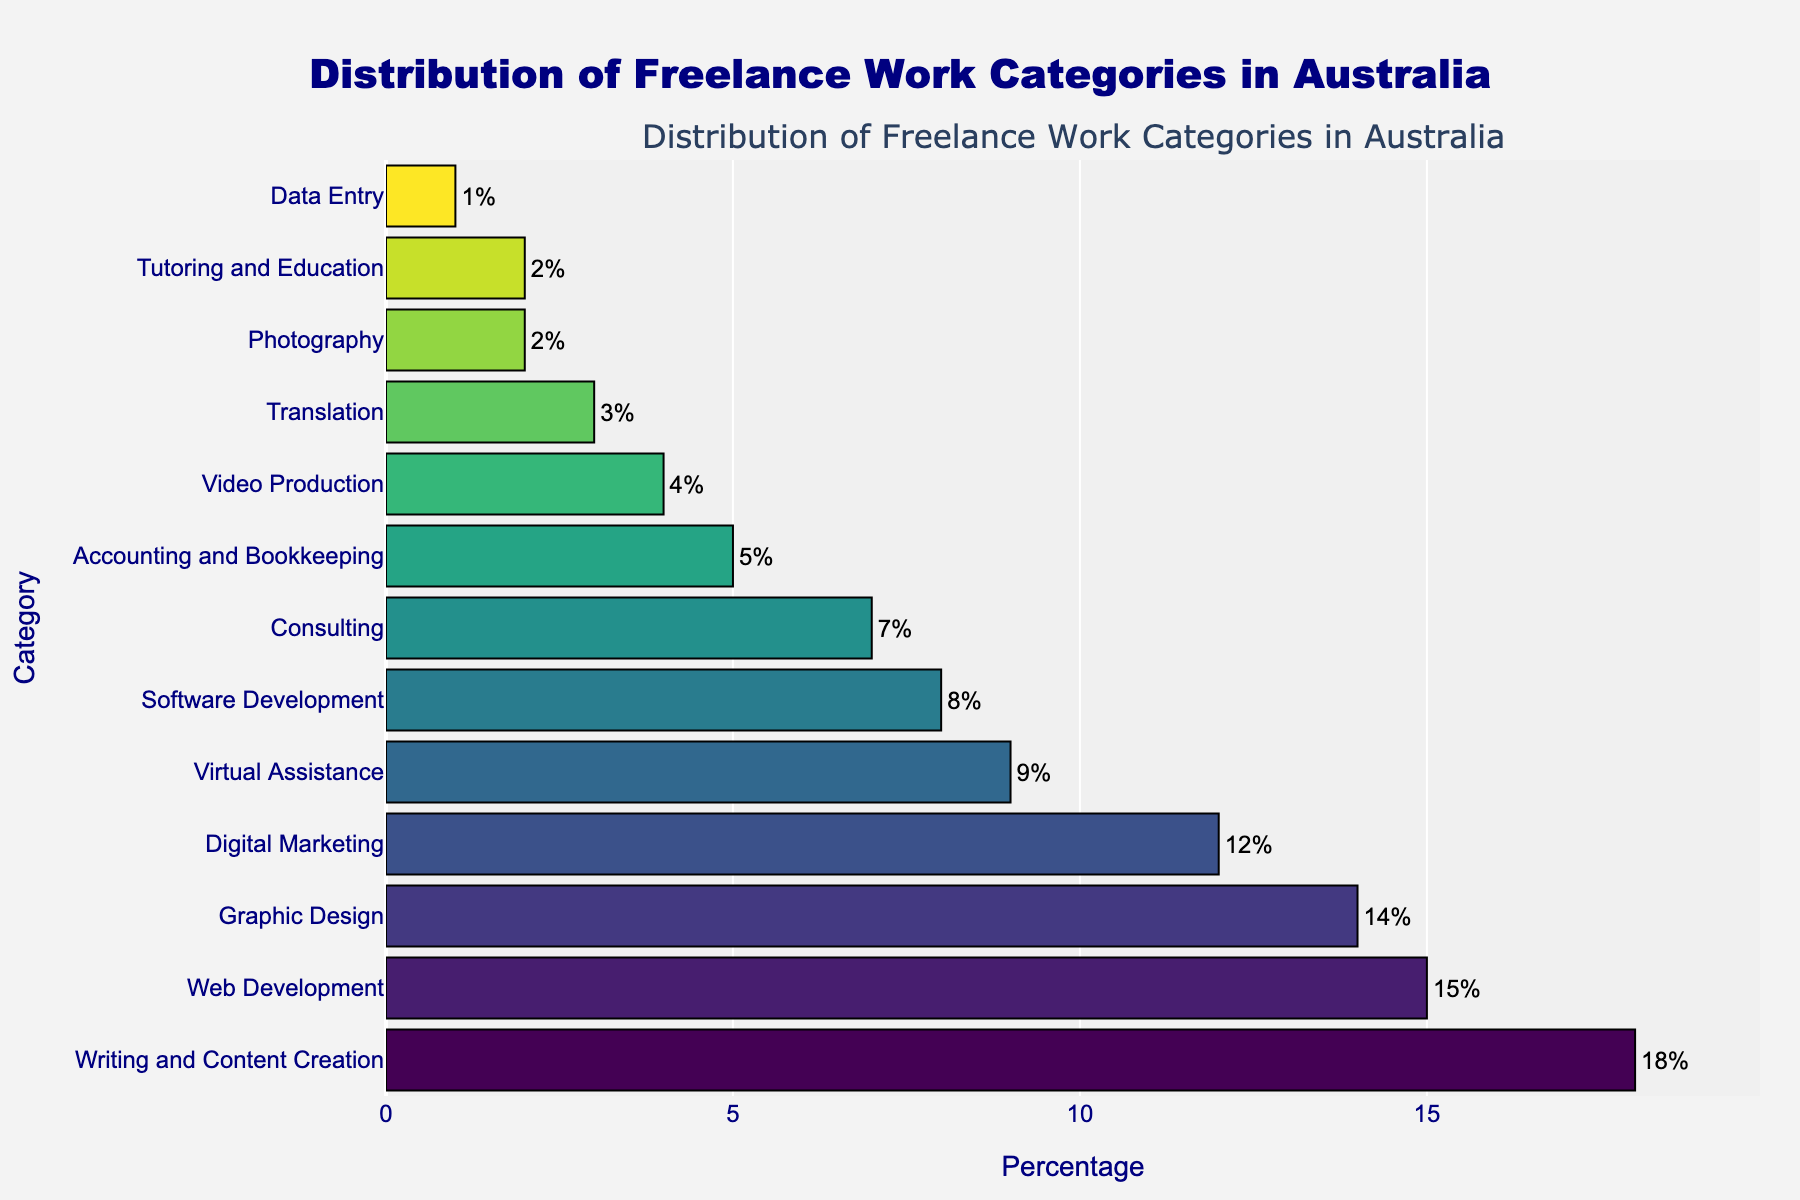What's the most common freelance work category in Australia based on the chart? The bar chart shows the distribution of freelance work categories. The category with the longest bar represents the highest percentage. In this case, "Writing and Content Creation" has the longest bar at 18%.
Answer: Writing and Content Creation Which freelance categories have a percentage of 10% or more? By observing the chart, we identify the bars with percentages 10% or higher: "Writing and Content Creation" (18%), "Web Development" (15%), "Graphic Design" (14%), and "Digital Marketing" (12%).
Answer: Writing and Content Creation, Web Development, Graphic Design, Digital Marketing What is the total percentage of the top 3 freelance work categories? The top 3 categories are "Writing and Content Creation" (18%), "Web Development" (15%), and "Graphic Design" (14%). Adding these gives 18% + 15% + 14% = 47%.
Answer: 47% Which categories have shorter bars than Virtual Assistance? Virtual Assistance has a percentage of 9%. Categories with shorter bars include "Software Development", "Consulting", "Accounting and Bookkeeping", "Video Production", "Translation", "Photography", "Tutoring and Education", and "Data Entry".
Answer: Software Development, Consulting, Accounting and Bookkeeping, Video Production, Translation, Photography, Tutoring and Education, Data Entry How much higher is the percentage of Writing and Content Creation compared to Digital Marketing? Writing and Content Creation is 18%, and Digital Marketing is 12%. The difference is 18% - 12% = 6%.
Answer: 6% Are there any categories with an equal percentage, and if so, which ones? By looking at the bars, we see that "Photography" and "Tutoring and Education" each have a percentage of 2%.
Answer: Photography, Tutoring and Education What's the percentage difference between the least common and the most common freelance categories? The least common category is "Data Entry" with 1%, and the most common is "Writing and Content Creation" with 18%. The difference is 18% - 1% = 17%.
Answer: 17% Which color represents the Web Development category in the chart, and how does it compare to Software Development? Web Development can be identified by locating its bar at 15%. The color for Web Development is further to the mid-range of the colorscale compared to Software Development's 8% bar, which is in the lower range of the scale.
Answer: Mid-range color for Web Development, lower range for Software Development How many categories have a percentage below 5%? The chart shows that the categories with percentages below 5% are "Video Production" (4%), "Translation" (3%), "Photography" (2%), "Tutoring and Education" (2%), and "Data Entry" (1%). There are 5 such categories.
Answer: 5 What visual characteristic helps distinguish the highest percentage category in the chart? The highest percentage category is "Writing and Content Creation" at 18%. This can be distinguished by its longer bar length compared to the others.
Answer: Longer bar length 